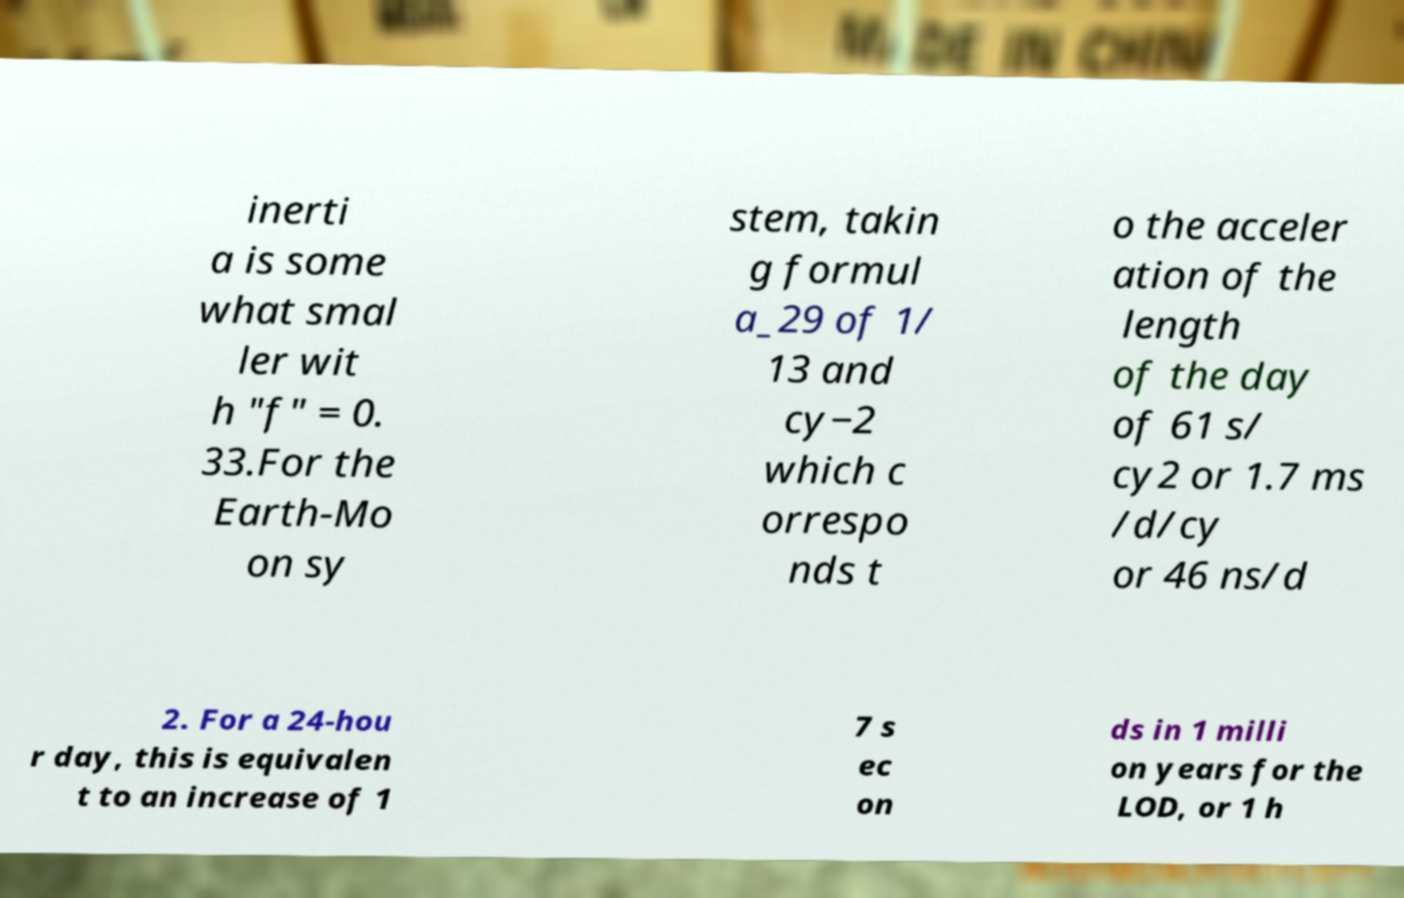I need the written content from this picture converted into text. Can you do that? inerti a is some what smal ler wit h "f" = 0. 33.For the Earth-Mo on sy stem, takin g formul a_29 of 1/ 13 and cy−2 which c orrespo nds t o the acceler ation of the length of the day of 61 s/ cy2 or 1.7 ms /d/cy or 46 ns/d 2. For a 24-hou r day, this is equivalen t to an increase of 1 7 s ec on ds in 1 milli on years for the LOD, or 1 h 